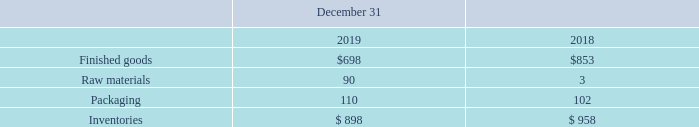NOTE 7. INVENTORIES
The following table details the components of inventories (in thousands).
What are the respective values of finished goods in 2018 and 2019?
Answer scale should be: thousand. $853, $698. What are the respective values of raw materials in 2018 and 2019?
Answer scale should be: thousand. 3, 90. What are the respective values of packaging in 2018 and 2019?
Answer scale should be: thousand. 102, 110. What is the average value of finished goods in 2018 and 2019?
Answer scale should be: thousand. (853 + 698)/2 
Answer: 775.5. What is the average value of raw materials in 2018 and 2019?
Answer scale should be: thousand. (90 + 3)/2 
Answer: 46.5. What is the average value of packaging in 2018 and 2019?
Answer scale should be: thousand. (110 + 102)/2 
Answer: 106. 